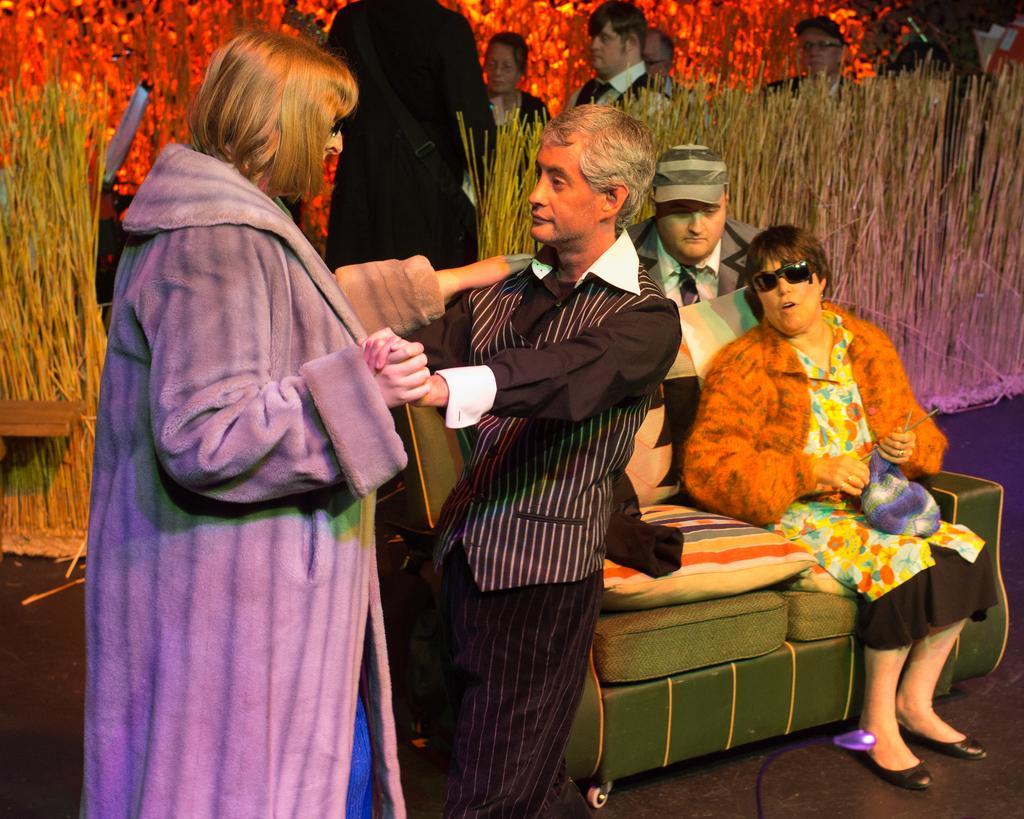Can you describe this image briefly? In this picture we can see some people are standing and some people are sitting on the couch. Behind the people there is the dry grass and other items. 